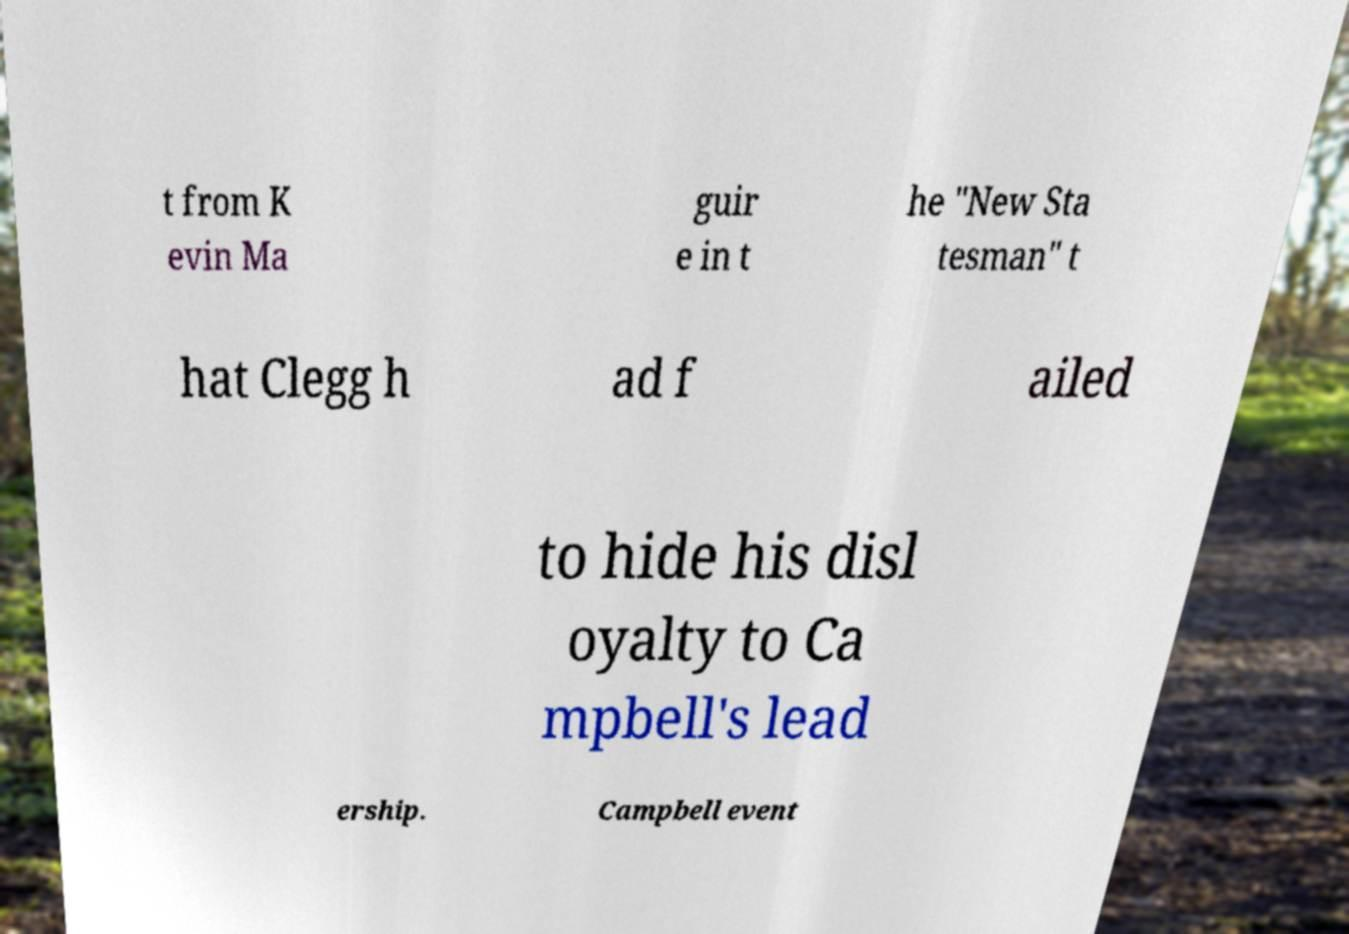Please identify and transcribe the text found in this image. t from K evin Ma guir e in t he "New Sta tesman" t hat Clegg h ad f ailed to hide his disl oyalty to Ca mpbell's lead ership. Campbell event 